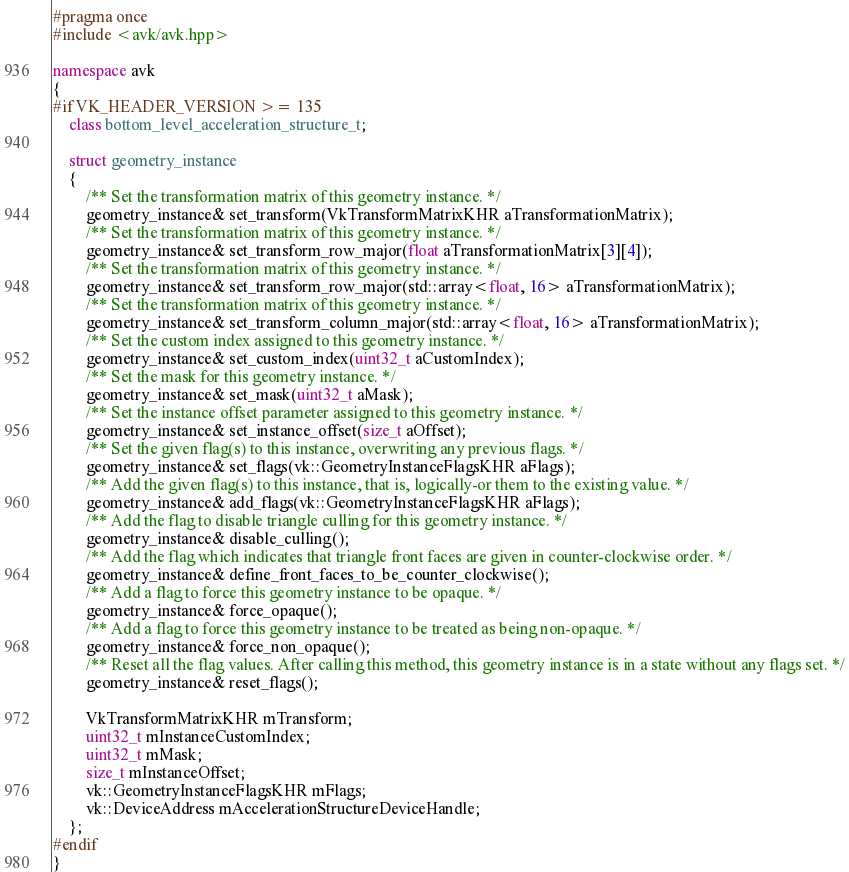<code> <loc_0><loc_0><loc_500><loc_500><_C++_>#pragma once
#include <avk/avk.hpp>

namespace avk
{
#if VK_HEADER_VERSION >= 135
	class bottom_level_acceleration_structure_t;

	struct geometry_instance
	{
		/** Set the transformation matrix of this geometry instance. */
		geometry_instance& set_transform(VkTransformMatrixKHR aTransformationMatrix);
		/** Set the transformation matrix of this geometry instance. */
		geometry_instance& set_transform_row_major(float aTransformationMatrix[3][4]);
		/** Set the transformation matrix of this geometry instance. */
		geometry_instance& set_transform_row_major(std::array<float, 16> aTransformationMatrix);
		/** Set the transformation matrix of this geometry instance. */
		geometry_instance& set_transform_column_major(std::array<float, 16> aTransformationMatrix);
		/** Set the custom index assigned to this geometry instance. */
		geometry_instance& set_custom_index(uint32_t aCustomIndex);
		/** Set the mask for this geometry instance. */
		geometry_instance& set_mask(uint32_t aMask);
		/** Set the instance offset parameter assigned to this geometry instance. */
		geometry_instance& set_instance_offset(size_t aOffset);
		/** Set the given flag(s) to this instance, overwriting any previous flags. */
		geometry_instance& set_flags(vk::GeometryInstanceFlagsKHR aFlags);
		/** Add the given flag(s) to this instance, that is, logically-or them to the existing value. */
		geometry_instance& add_flags(vk::GeometryInstanceFlagsKHR aFlags);
		/** Add the flag to disable triangle culling for this geometry instance. */
		geometry_instance& disable_culling();
		/** Add the flag which indicates that triangle front faces are given in counter-clockwise order. */
		geometry_instance& define_front_faces_to_be_counter_clockwise();
		/** Add a flag to force this geometry instance to be opaque. */
		geometry_instance& force_opaque();
		/** Add a flag to force this geometry instance to be treated as being non-opaque. */
		geometry_instance& force_non_opaque();
		/** Reset all the flag values. After calling this method, this geometry instance is in a state without any flags set. */
		geometry_instance& reset_flags();

		VkTransformMatrixKHR mTransform;
		uint32_t mInstanceCustomIndex;
		uint32_t mMask;
		size_t mInstanceOffset;
		vk::GeometryInstanceFlagsKHR mFlags;
		vk::DeviceAddress mAccelerationStructureDeviceHandle;
	};
#endif
}</code> 